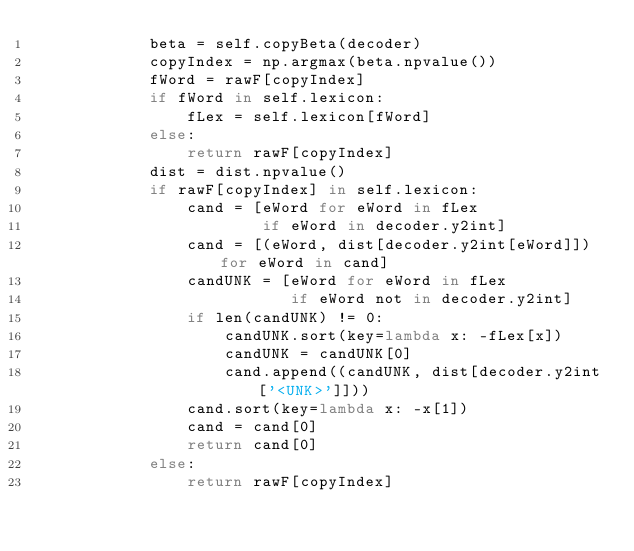<code> <loc_0><loc_0><loc_500><loc_500><_Cython_>            beta = self.copyBeta(decoder)
            copyIndex = np.argmax(beta.npvalue())
            fWord = rawF[copyIndex]
            if fWord in self.lexicon:
                fLex = self.lexicon[fWord]
            else:
                return rawF[copyIndex]
            dist = dist.npvalue()
            if rawF[copyIndex] in self.lexicon:
                cand = [eWord for eWord in fLex
                        if eWord in decoder.y2int]
                cand = [(eWord, dist[decoder.y2int[eWord]]) for eWord in cand]
                candUNK = [eWord for eWord in fLex
                           if eWord not in decoder.y2int]
                if len(candUNK) != 0:
                    candUNK.sort(key=lambda x: -fLex[x])
                    candUNK = candUNK[0]
                    cand.append((candUNK, dist[decoder.y2int['<UNK>']]))
                cand.sort(key=lambda x: -x[1])
                cand = cand[0]
                return cand[0]
            else:
                return rawF[copyIndex]
</code> 